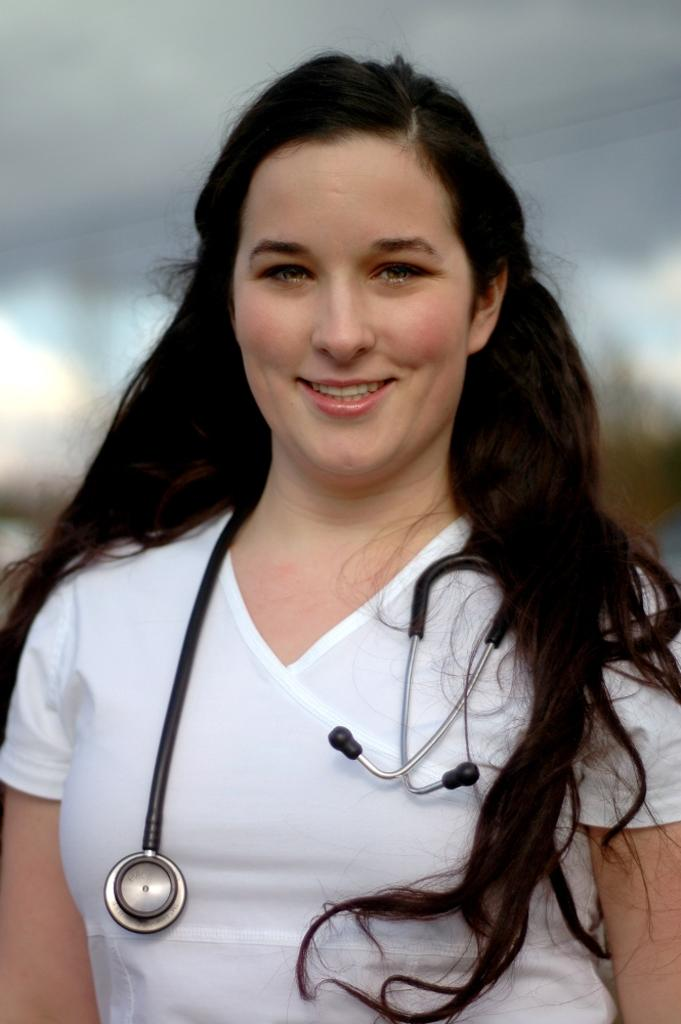What is the main subject of the image? The main subject of the image is a woman. What is the woman doing in the image? The woman is standing in the image. What object is the woman holding in the image? The woman is holding a stethoscope in the image. What type of pancake is the woman flipping in the image? There is no pancake present in the image; the woman is holding a stethoscope. 